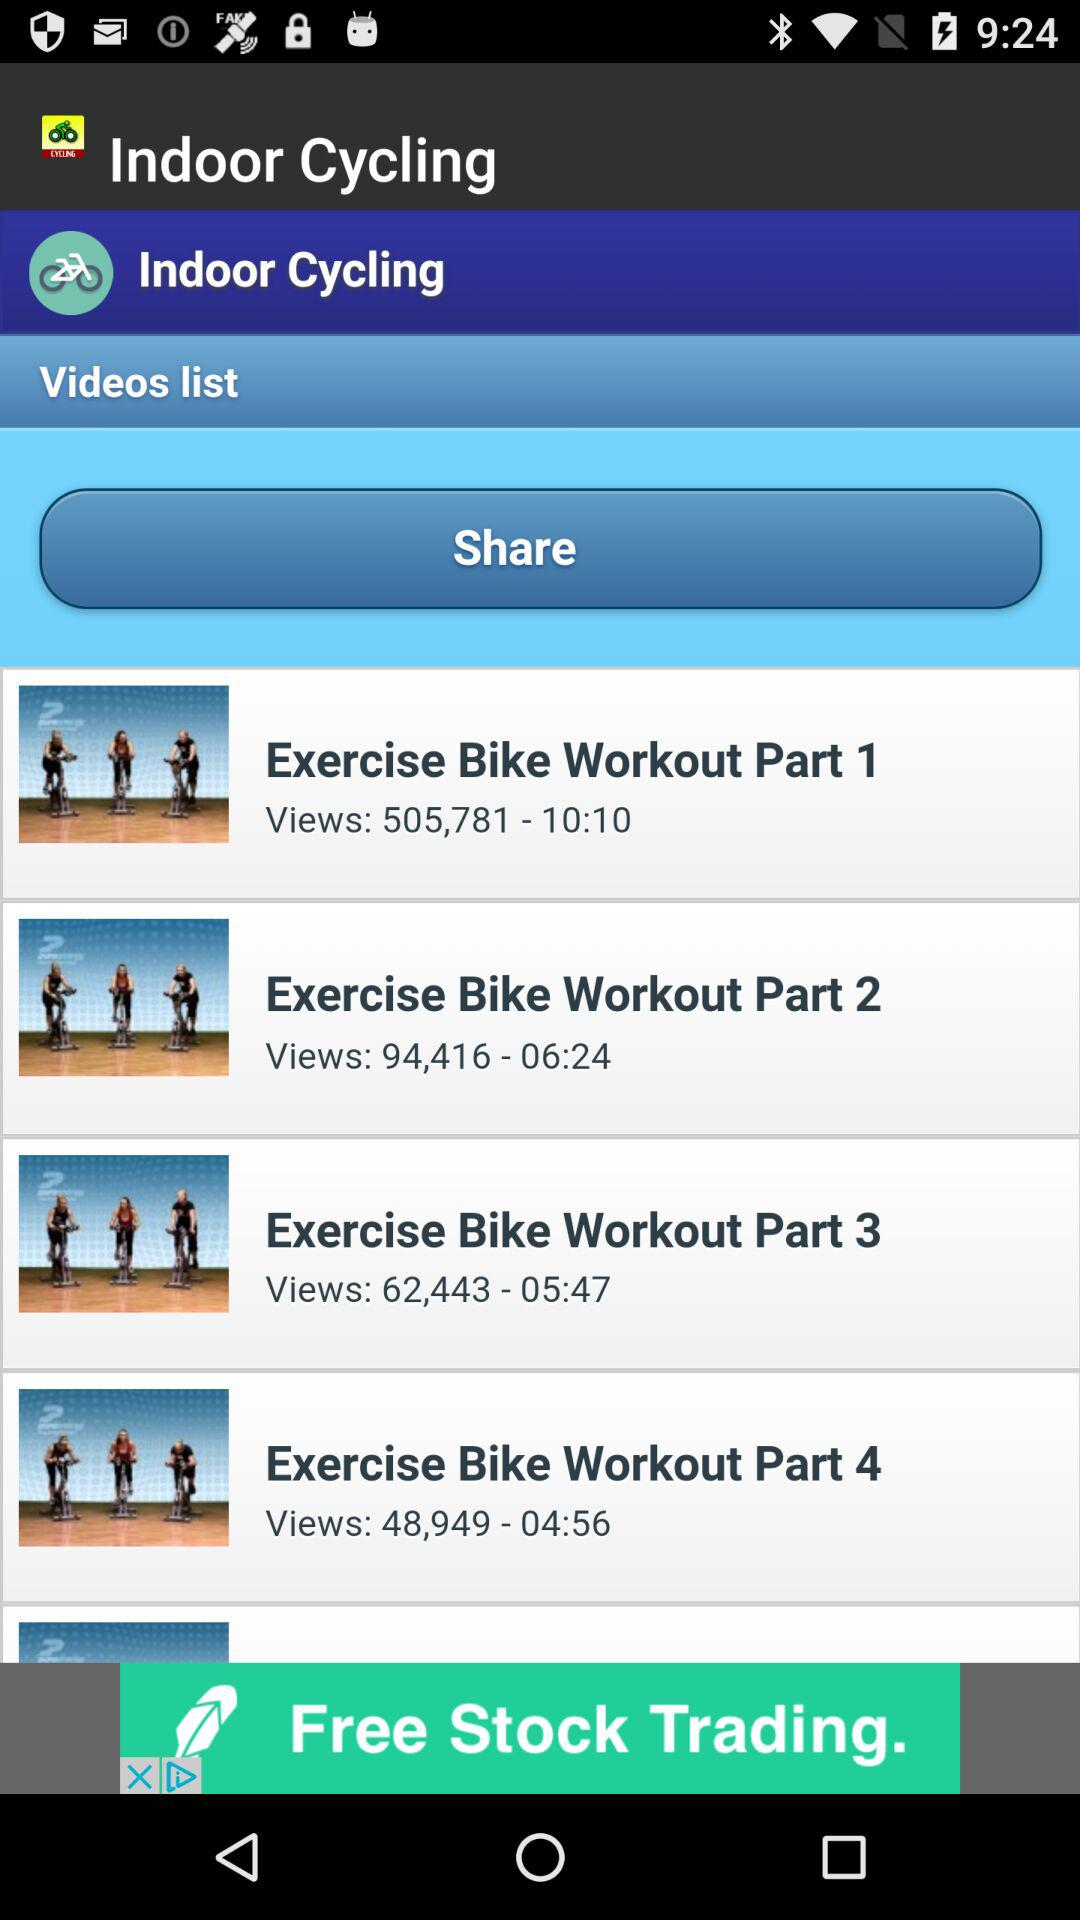What is the duration of "Exercise Bike Workout Part 2"? The duration of "Exercise Bike Workout Part 2" is 6 minutes 24 seconds. 